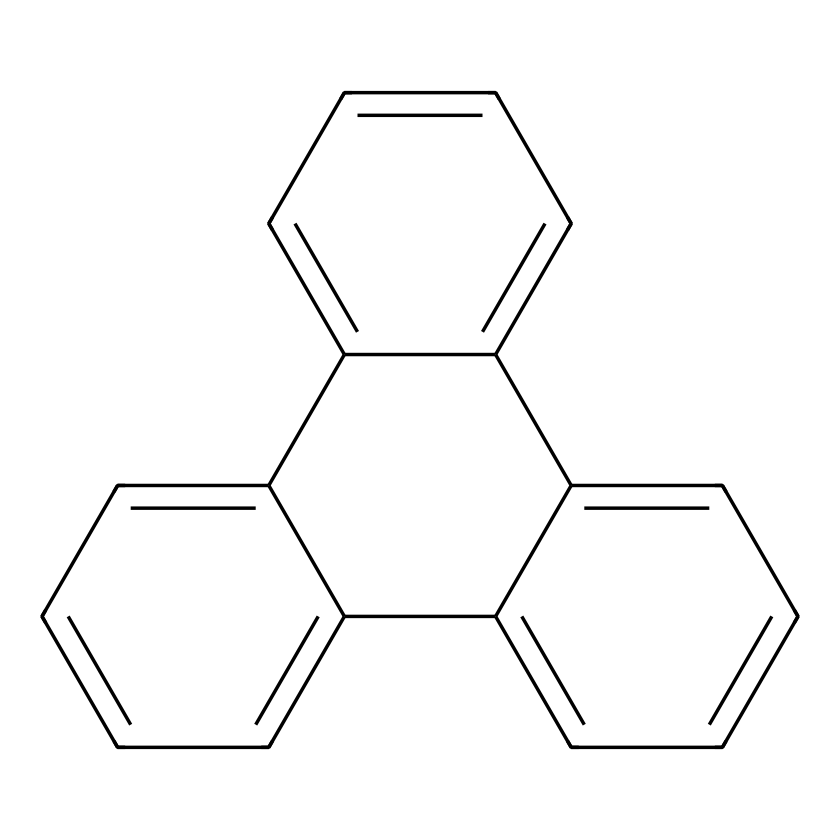What is the name of this chemical? The given SMILES representation corresponds to phenanthrene, which consists of three fused benzene rings in a specific arrangement. The molecular structure indicates it follows the characteristics of polycyclic aromatic hydrocarbons.
Answer: phenanthrene How many carbon atoms are in the structure? To determine the number of carbon atoms, I count the carbon atoms represented in the structure derived from the SMILES. The fused rings and their arrangement indicate there are 14 carbon atoms in total.
Answer: 14 What type of bonds are present in this molecule? The molecular structure's alternating single and double bonds indicates that phenanthrene has both sigma and pi bonds characteristic of aromatic compounds.
Answer: aromatic How many hydrogen atoms are bonded to this molecule? Each carbon in the benzene rings can form up to four bonds, considering the present double bonds reduces the number of hydrogens. By calculating from the structure derived from the SMILES, phenanthrene has 10 hydrogen atoms.
Answer: 10 Is this compound polar or nonpolar? The structure reveals a symmetrical arrangement of carbon and hydrogen atoms without significant electronegative substituents, leading to a nonpolar character for the molecule due to lack of polarity in C-H bonds.
Answer: nonpolar Can phenanthrene undergo electrophilic substitution reactions? Given that phenanthrene is an aromatic hydrocarbon, it retains the stability of the aromatic system, allowing it to readily undergo electrophilic substitution reactions, a characteristic behavior of aromatic compounds.
Answer: yes 